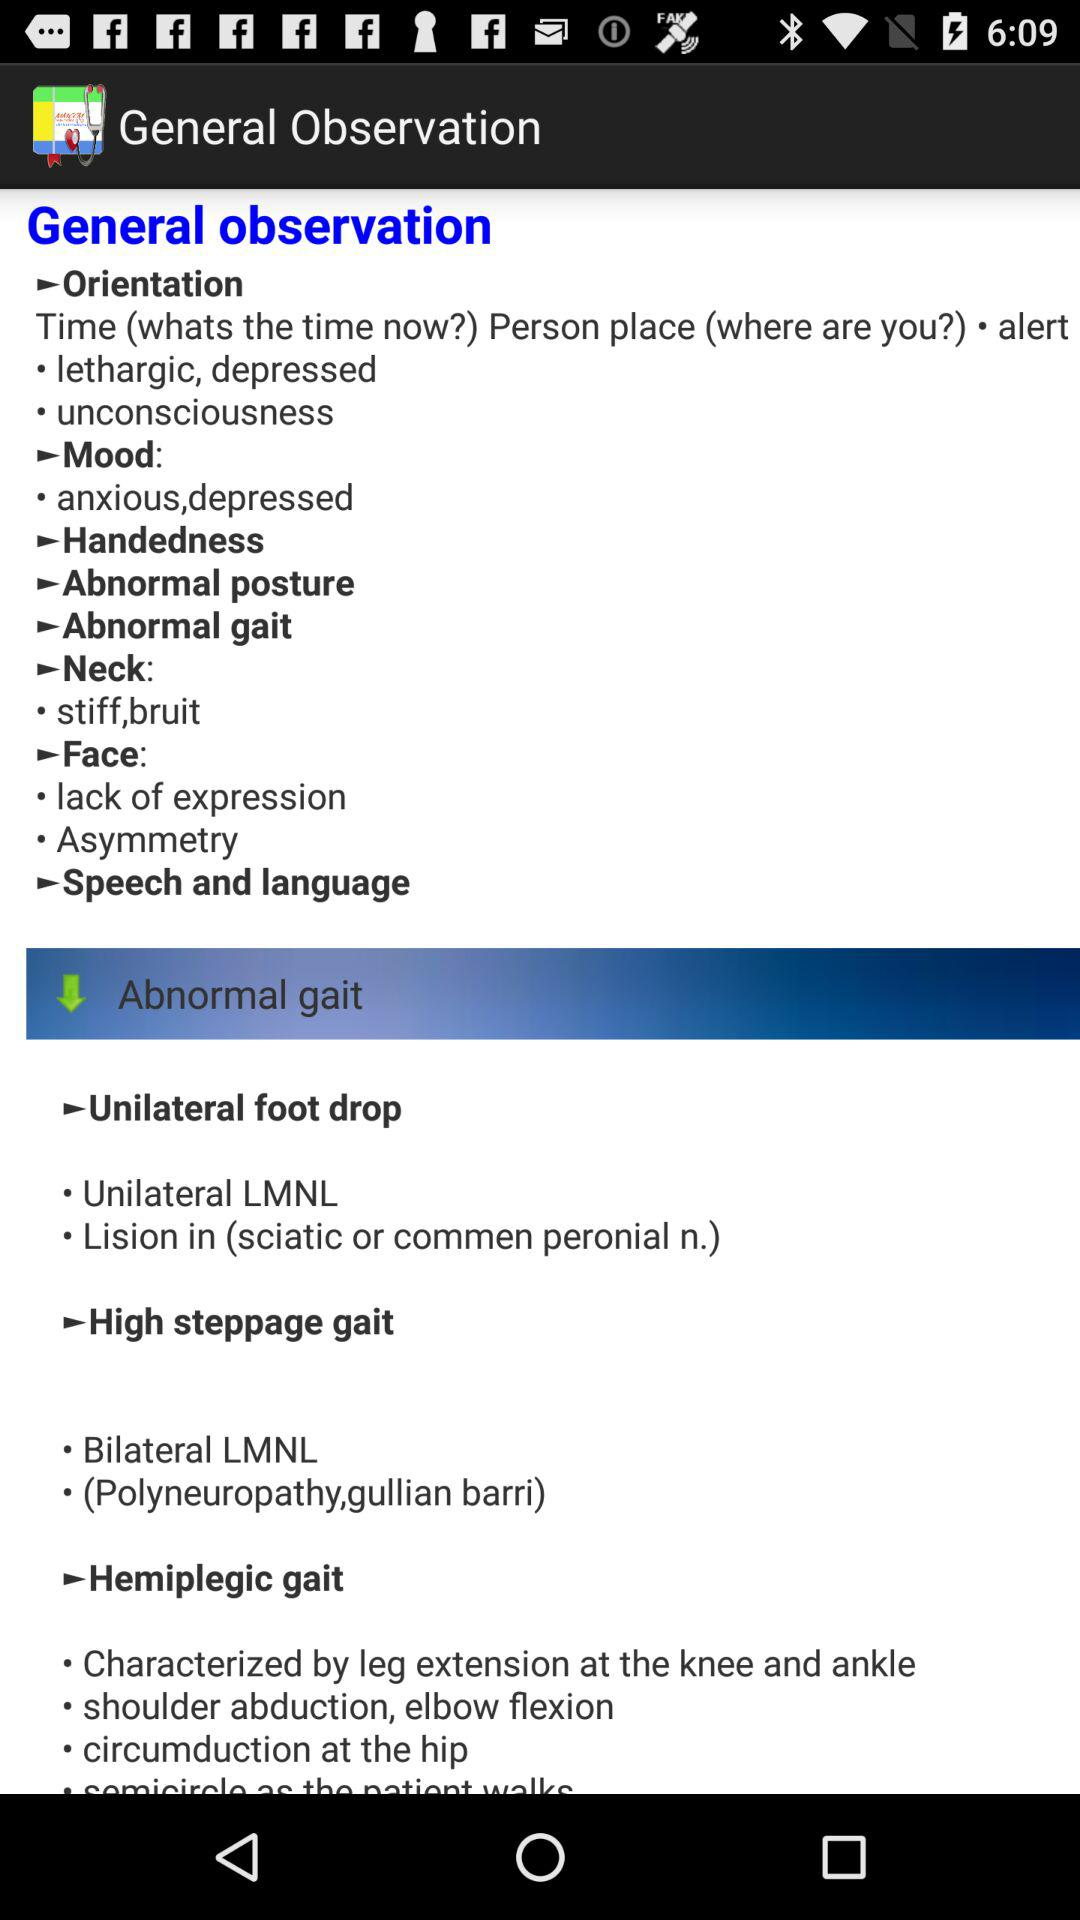How many items under the 'Abnormal gait' section are preceded by a bullet point?
Answer the question using a single word or phrase. 3 